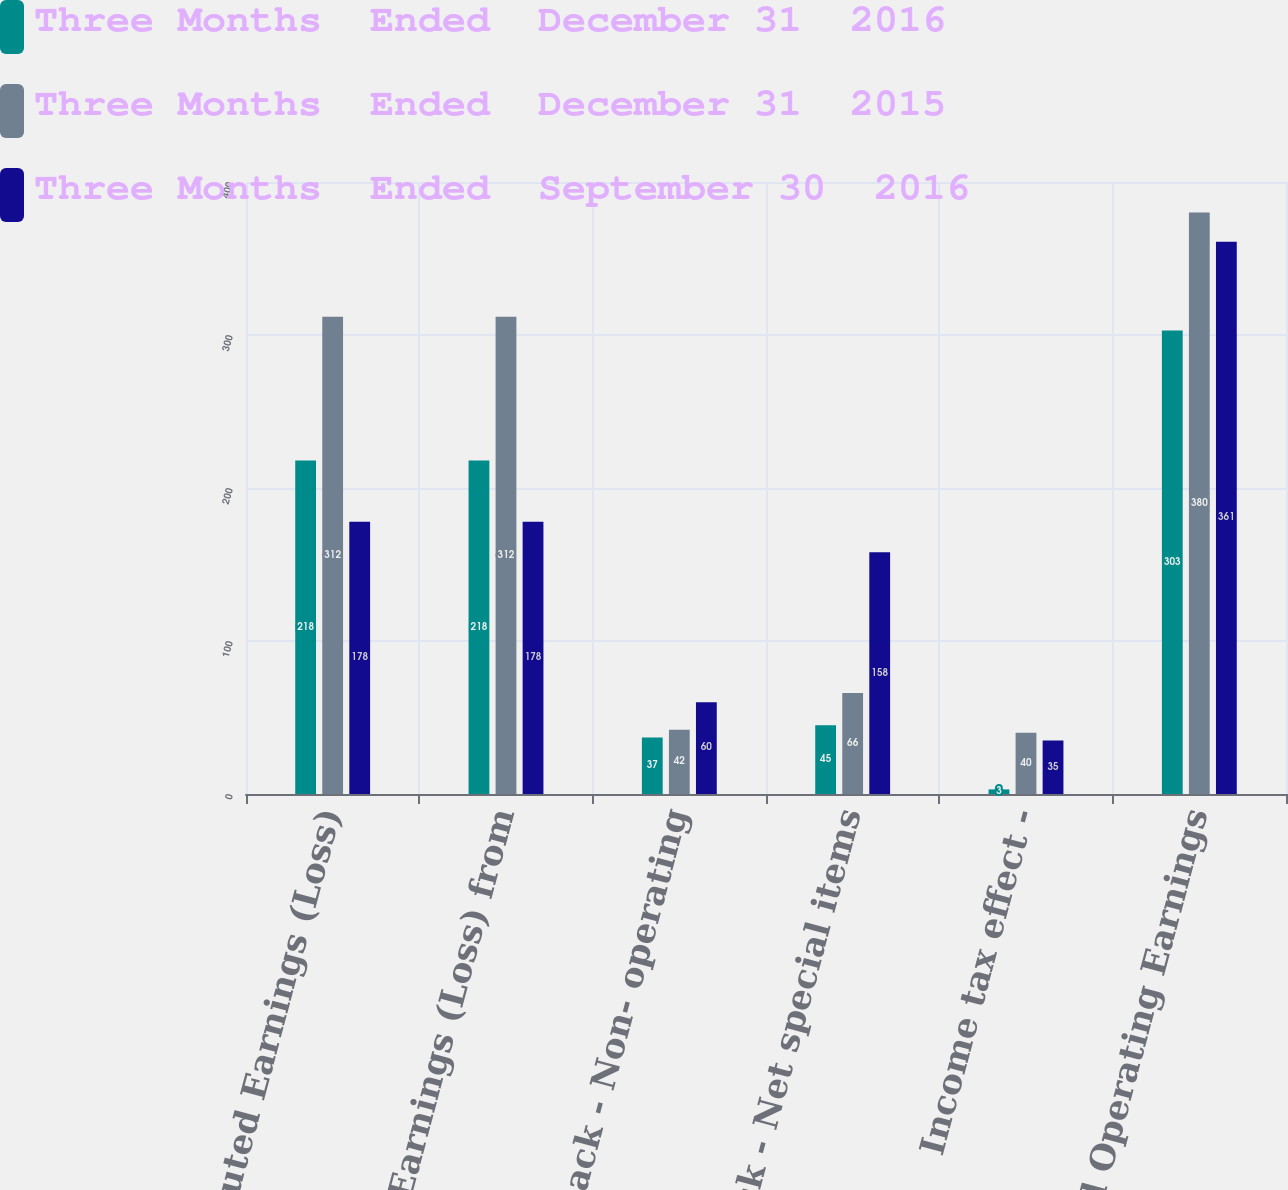<chart> <loc_0><loc_0><loc_500><loc_500><stacked_bar_chart><ecel><fcel>Diluted Earnings (Loss)<fcel>Diluted Earnings (Loss) from<fcel>Add back - Non- operating<fcel>Add back - Net special items<fcel>Income tax effect -<fcel>Adjusted Operating Earnings<nl><fcel>Three Months  Ended  December 31  2016<fcel>218<fcel>218<fcel>37<fcel>45<fcel>3<fcel>303<nl><fcel>Three Months  Ended  December 31  2015<fcel>312<fcel>312<fcel>42<fcel>66<fcel>40<fcel>380<nl><fcel>Three Months  Ended  September 30  2016<fcel>178<fcel>178<fcel>60<fcel>158<fcel>35<fcel>361<nl></chart> 